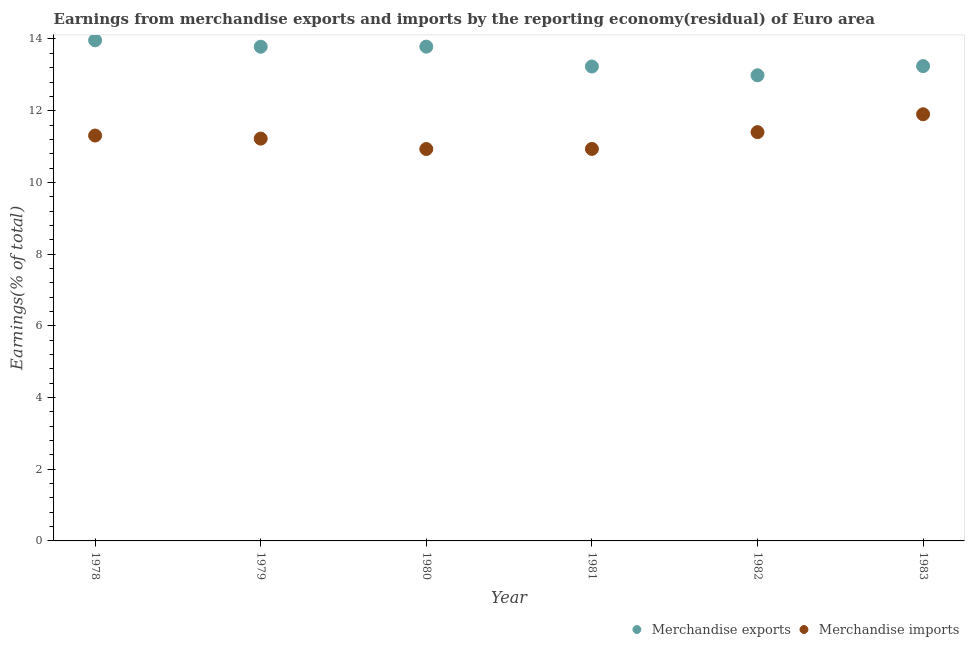Is the number of dotlines equal to the number of legend labels?
Your answer should be very brief. Yes. What is the earnings from merchandise exports in 1983?
Ensure brevity in your answer.  13.24. Across all years, what is the maximum earnings from merchandise exports?
Give a very brief answer. 13.96. Across all years, what is the minimum earnings from merchandise imports?
Keep it short and to the point. 10.93. In which year was the earnings from merchandise exports maximum?
Offer a very short reply. 1978. What is the total earnings from merchandise imports in the graph?
Give a very brief answer. 67.7. What is the difference between the earnings from merchandise imports in 1981 and that in 1983?
Provide a succinct answer. -0.97. What is the difference between the earnings from merchandise imports in 1979 and the earnings from merchandise exports in 1978?
Your response must be concise. -2.74. What is the average earnings from merchandise imports per year?
Your response must be concise. 11.28. In the year 1980, what is the difference between the earnings from merchandise imports and earnings from merchandise exports?
Provide a short and direct response. -2.86. What is the ratio of the earnings from merchandise exports in 1979 to that in 1982?
Your answer should be compact. 1.06. What is the difference between the highest and the second highest earnings from merchandise imports?
Give a very brief answer. 0.5. What is the difference between the highest and the lowest earnings from merchandise imports?
Give a very brief answer. 0.97. Is the sum of the earnings from merchandise exports in 1978 and 1983 greater than the maximum earnings from merchandise imports across all years?
Provide a short and direct response. Yes. Does the earnings from merchandise exports monotonically increase over the years?
Offer a terse response. No. Is the earnings from merchandise imports strictly greater than the earnings from merchandise exports over the years?
Your answer should be very brief. No. Is the earnings from merchandise imports strictly less than the earnings from merchandise exports over the years?
Your answer should be compact. Yes. How many years are there in the graph?
Your response must be concise. 6. What is the difference between two consecutive major ticks on the Y-axis?
Your answer should be very brief. 2. Does the graph contain any zero values?
Provide a succinct answer. No. Does the graph contain grids?
Offer a terse response. No. Where does the legend appear in the graph?
Provide a succinct answer. Bottom right. How are the legend labels stacked?
Make the answer very short. Horizontal. What is the title of the graph?
Keep it short and to the point. Earnings from merchandise exports and imports by the reporting economy(residual) of Euro area. Does "Rural Population" appear as one of the legend labels in the graph?
Give a very brief answer. No. What is the label or title of the X-axis?
Ensure brevity in your answer.  Year. What is the label or title of the Y-axis?
Keep it short and to the point. Earnings(% of total). What is the Earnings(% of total) of Merchandise exports in 1978?
Your answer should be very brief. 13.96. What is the Earnings(% of total) in Merchandise imports in 1978?
Provide a short and direct response. 11.31. What is the Earnings(% of total) in Merchandise exports in 1979?
Make the answer very short. 13.78. What is the Earnings(% of total) of Merchandise imports in 1979?
Make the answer very short. 11.22. What is the Earnings(% of total) in Merchandise exports in 1980?
Your answer should be very brief. 13.79. What is the Earnings(% of total) in Merchandise imports in 1980?
Provide a succinct answer. 10.93. What is the Earnings(% of total) of Merchandise exports in 1981?
Provide a succinct answer. 13.23. What is the Earnings(% of total) of Merchandise imports in 1981?
Offer a terse response. 10.93. What is the Earnings(% of total) in Merchandise exports in 1982?
Provide a short and direct response. 12.99. What is the Earnings(% of total) in Merchandise imports in 1982?
Your answer should be compact. 11.4. What is the Earnings(% of total) in Merchandise exports in 1983?
Provide a short and direct response. 13.24. What is the Earnings(% of total) of Merchandise imports in 1983?
Your answer should be very brief. 11.9. Across all years, what is the maximum Earnings(% of total) of Merchandise exports?
Provide a short and direct response. 13.96. Across all years, what is the maximum Earnings(% of total) of Merchandise imports?
Keep it short and to the point. 11.9. Across all years, what is the minimum Earnings(% of total) of Merchandise exports?
Make the answer very short. 12.99. Across all years, what is the minimum Earnings(% of total) in Merchandise imports?
Offer a terse response. 10.93. What is the total Earnings(% of total) of Merchandise exports in the graph?
Provide a succinct answer. 81. What is the total Earnings(% of total) in Merchandise imports in the graph?
Ensure brevity in your answer.  67.7. What is the difference between the Earnings(% of total) in Merchandise exports in 1978 and that in 1979?
Your answer should be compact. 0.18. What is the difference between the Earnings(% of total) of Merchandise imports in 1978 and that in 1979?
Give a very brief answer. 0.09. What is the difference between the Earnings(% of total) in Merchandise exports in 1978 and that in 1980?
Ensure brevity in your answer.  0.18. What is the difference between the Earnings(% of total) of Merchandise imports in 1978 and that in 1980?
Your answer should be compact. 0.38. What is the difference between the Earnings(% of total) of Merchandise exports in 1978 and that in 1981?
Give a very brief answer. 0.73. What is the difference between the Earnings(% of total) of Merchandise imports in 1978 and that in 1981?
Offer a terse response. 0.37. What is the difference between the Earnings(% of total) in Merchandise exports in 1978 and that in 1982?
Make the answer very short. 0.98. What is the difference between the Earnings(% of total) in Merchandise imports in 1978 and that in 1982?
Provide a short and direct response. -0.1. What is the difference between the Earnings(% of total) of Merchandise exports in 1978 and that in 1983?
Your answer should be very brief. 0.72. What is the difference between the Earnings(% of total) in Merchandise imports in 1978 and that in 1983?
Offer a very short reply. -0.59. What is the difference between the Earnings(% of total) in Merchandise exports in 1979 and that in 1980?
Offer a very short reply. -0. What is the difference between the Earnings(% of total) in Merchandise imports in 1979 and that in 1980?
Make the answer very short. 0.29. What is the difference between the Earnings(% of total) in Merchandise exports in 1979 and that in 1981?
Ensure brevity in your answer.  0.55. What is the difference between the Earnings(% of total) in Merchandise imports in 1979 and that in 1981?
Make the answer very short. 0.29. What is the difference between the Earnings(% of total) of Merchandise exports in 1979 and that in 1982?
Make the answer very short. 0.8. What is the difference between the Earnings(% of total) of Merchandise imports in 1979 and that in 1982?
Your response must be concise. -0.18. What is the difference between the Earnings(% of total) of Merchandise exports in 1979 and that in 1983?
Offer a very short reply. 0.54. What is the difference between the Earnings(% of total) of Merchandise imports in 1979 and that in 1983?
Provide a short and direct response. -0.68. What is the difference between the Earnings(% of total) of Merchandise exports in 1980 and that in 1981?
Your answer should be very brief. 0.55. What is the difference between the Earnings(% of total) of Merchandise imports in 1980 and that in 1981?
Give a very brief answer. -0. What is the difference between the Earnings(% of total) of Merchandise exports in 1980 and that in 1982?
Give a very brief answer. 0.8. What is the difference between the Earnings(% of total) of Merchandise imports in 1980 and that in 1982?
Give a very brief answer. -0.47. What is the difference between the Earnings(% of total) of Merchandise exports in 1980 and that in 1983?
Make the answer very short. 0.54. What is the difference between the Earnings(% of total) of Merchandise imports in 1980 and that in 1983?
Ensure brevity in your answer.  -0.97. What is the difference between the Earnings(% of total) in Merchandise exports in 1981 and that in 1982?
Offer a very short reply. 0.24. What is the difference between the Earnings(% of total) of Merchandise imports in 1981 and that in 1982?
Provide a short and direct response. -0.47. What is the difference between the Earnings(% of total) in Merchandise exports in 1981 and that in 1983?
Your answer should be compact. -0.01. What is the difference between the Earnings(% of total) in Merchandise imports in 1981 and that in 1983?
Offer a very short reply. -0.97. What is the difference between the Earnings(% of total) of Merchandise exports in 1982 and that in 1983?
Provide a short and direct response. -0.26. What is the difference between the Earnings(% of total) of Merchandise imports in 1982 and that in 1983?
Ensure brevity in your answer.  -0.5. What is the difference between the Earnings(% of total) of Merchandise exports in 1978 and the Earnings(% of total) of Merchandise imports in 1979?
Your response must be concise. 2.74. What is the difference between the Earnings(% of total) in Merchandise exports in 1978 and the Earnings(% of total) in Merchandise imports in 1980?
Keep it short and to the point. 3.03. What is the difference between the Earnings(% of total) in Merchandise exports in 1978 and the Earnings(% of total) in Merchandise imports in 1981?
Keep it short and to the point. 3.03. What is the difference between the Earnings(% of total) in Merchandise exports in 1978 and the Earnings(% of total) in Merchandise imports in 1982?
Your answer should be compact. 2.56. What is the difference between the Earnings(% of total) in Merchandise exports in 1978 and the Earnings(% of total) in Merchandise imports in 1983?
Offer a terse response. 2.06. What is the difference between the Earnings(% of total) of Merchandise exports in 1979 and the Earnings(% of total) of Merchandise imports in 1980?
Provide a succinct answer. 2.85. What is the difference between the Earnings(% of total) in Merchandise exports in 1979 and the Earnings(% of total) in Merchandise imports in 1981?
Provide a succinct answer. 2.85. What is the difference between the Earnings(% of total) of Merchandise exports in 1979 and the Earnings(% of total) of Merchandise imports in 1982?
Keep it short and to the point. 2.38. What is the difference between the Earnings(% of total) in Merchandise exports in 1979 and the Earnings(% of total) in Merchandise imports in 1983?
Offer a very short reply. 1.88. What is the difference between the Earnings(% of total) in Merchandise exports in 1980 and the Earnings(% of total) in Merchandise imports in 1981?
Make the answer very short. 2.85. What is the difference between the Earnings(% of total) in Merchandise exports in 1980 and the Earnings(% of total) in Merchandise imports in 1982?
Give a very brief answer. 2.38. What is the difference between the Earnings(% of total) in Merchandise exports in 1980 and the Earnings(% of total) in Merchandise imports in 1983?
Provide a short and direct response. 1.89. What is the difference between the Earnings(% of total) in Merchandise exports in 1981 and the Earnings(% of total) in Merchandise imports in 1982?
Your answer should be compact. 1.83. What is the difference between the Earnings(% of total) of Merchandise exports in 1981 and the Earnings(% of total) of Merchandise imports in 1983?
Provide a short and direct response. 1.33. What is the difference between the Earnings(% of total) in Merchandise exports in 1982 and the Earnings(% of total) in Merchandise imports in 1983?
Offer a very short reply. 1.09. What is the average Earnings(% of total) of Merchandise exports per year?
Provide a succinct answer. 13.5. What is the average Earnings(% of total) in Merchandise imports per year?
Make the answer very short. 11.28. In the year 1978, what is the difference between the Earnings(% of total) of Merchandise exports and Earnings(% of total) of Merchandise imports?
Ensure brevity in your answer.  2.66. In the year 1979, what is the difference between the Earnings(% of total) of Merchandise exports and Earnings(% of total) of Merchandise imports?
Provide a succinct answer. 2.56. In the year 1980, what is the difference between the Earnings(% of total) of Merchandise exports and Earnings(% of total) of Merchandise imports?
Make the answer very short. 2.86. In the year 1981, what is the difference between the Earnings(% of total) in Merchandise exports and Earnings(% of total) in Merchandise imports?
Ensure brevity in your answer.  2.3. In the year 1982, what is the difference between the Earnings(% of total) of Merchandise exports and Earnings(% of total) of Merchandise imports?
Offer a very short reply. 1.59. In the year 1983, what is the difference between the Earnings(% of total) of Merchandise exports and Earnings(% of total) of Merchandise imports?
Keep it short and to the point. 1.34. What is the ratio of the Earnings(% of total) in Merchandise exports in 1978 to that in 1979?
Offer a terse response. 1.01. What is the ratio of the Earnings(% of total) in Merchandise imports in 1978 to that in 1979?
Offer a terse response. 1.01. What is the ratio of the Earnings(% of total) in Merchandise exports in 1978 to that in 1980?
Offer a terse response. 1.01. What is the ratio of the Earnings(% of total) of Merchandise imports in 1978 to that in 1980?
Your response must be concise. 1.03. What is the ratio of the Earnings(% of total) of Merchandise exports in 1978 to that in 1981?
Provide a short and direct response. 1.06. What is the ratio of the Earnings(% of total) of Merchandise imports in 1978 to that in 1981?
Make the answer very short. 1.03. What is the ratio of the Earnings(% of total) of Merchandise exports in 1978 to that in 1982?
Provide a succinct answer. 1.08. What is the ratio of the Earnings(% of total) in Merchandise exports in 1978 to that in 1983?
Your response must be concise. 1.05. What is the ratio of the Earnings(% of total) in Merchandise imports in 1978 to that in 1983?
Ensure brevity in your answer.  0.95. What is the ratio of the Earnings(% of total) in Merchandise exports in 1979 to that in 1980?
Offer a very short reply. 1. What is the ratio of the Earnings(% of total) of Merchandise imports in 1979 to that in 1980?
Give a very brief answer. 1.03. What is the ratio of the Earnings(% of total) in Merchandise exports in 1979 to that in 1981?
Offer a very short reply. 1.04. What is the ratio of the Earnings(% of total) in Merchandise imports in 1979 to that in 1981?
Ensure brevity in your answer.  1.03. What is the ratio of the Earnings(% of total) of Merchandise exports in 1979 to that in 1982?
Your answer should be compact. 1.06. What is the ratio of the Earnings(% of total) in Merchandise imports in 1979 to that in 1982?
Provide a succinct answer. 0.98. What is the ratio of the Earnings(% of total) of Merchandise exports in 1979 to that in 1983?
Your answer should be very brief. 1.04. What is the ratio of the Earnings(% of total) in Merchandise imports in 1979 to that in 1983?
Offer a terse response. 0.94. What is the ratio of the Earnings(% of total) of Merchandise exports in 1980 to that in 1981?
Make the answer very short. 1.04. What is the ratio of the Earnings(% of total) in Merchandise exports in 1980 to that in 1982?
Keep it short and to the point. 1.06. What is the ratio of the Earnings(% of total) of Merchandise imports in 1980 to that in 1982?
Make the answer very short. 0.96. What is the ratio of the Earnings(% of total) of Merchandise exports in 1980 to that in 1983?
Offer a very short reply. 1.04. What is the ratio of the Earnings(% of total) in Merchandise imports in 1980 to that in 1983?
Your answer should be compact. 0.92. What is the ratio of the Earnings(% of total) of Merchandise exports in 1981 to that in 1982?
Provide a short and direct response. 1.02. What is the ratio of the Earnings(% of total) in Merchandise exports in 1981 to that in 1983?
Your response must be concise. 1. What is the ratio of the Earnings(% of total) in Merchandise imports in 1981 to that in 1983?
Your answer should be very brief. 0.92. What is the ratio of the Earnings(% of total) in Merchandise exports in 1982 to that in 1983?
Keep it short and to the point. 0.98. What is the ratio of the Earnings(% of total) in Merchandise imports in 1982 to that in 1983?
Ensure brevity in your answer.  0.96. What is the difference between the highest and the second highest Earnings(% of total) of Merchandise exports?
Keep it short and to the point. 0.18. What is the difference between the highest and the second highest Earnings(% of total) in Merchandise imports?
Your answer should be very brief. 0.5. What is the difference between the highest and the lowest Earnings(% of total) in Merchandise exports?
Keep it short and to the point. 0.98. What is the difference between the highest and the lowest Earnings(% of total) of Merchandise imports?
Your response must be concise. 0.97. 